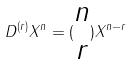<formula> <loc_0><loc_0><loc_500><loc_500>D ^ { ( r ) } X ^ { n } = ( \begin{matrix} n \\ r \end{matrix} ) X ^ { n - r }</formula> 